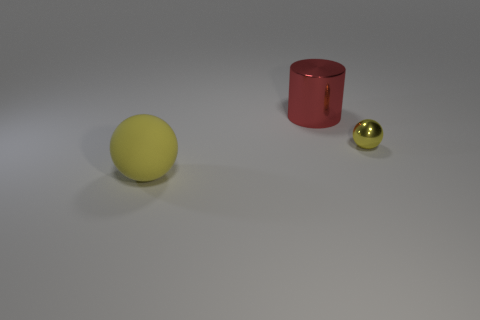There is a large object in front of the big red thing; is its shape the same as the red metallic thing?
Your answer should be very brief. No. How many things are either yellow objects or large red cylinders?
Offer a very short reply. 3. Is the object that is to the left of the large cylinder made of the same material as the red thing?
Your answer should be compact. No. The red metal thing is what size?
Provide a short and direct response. Large. There is a metal object that is the same color as the large rubber sphere; what is its shape?
Your answer should be very brief. Sphere. What number of blocks are large yellow rubber things or big red things?
Ensure brevity in your answer.  0. Are there an equal number of large balls that are in front of the large sphere and large yellow rubber balls that are to the left of the red cylinder?
Make the answer very short. No. There is a metal thing that is the same shape as the matte object; what is its size?
Your answer should be compact. Small. There is a thing that is behind the matte object and in front of the red metallic cylinder; how big is it?
Your answer should be compact. Small. There is a yellow shiny object; are there any big yellow rubber objects behind it?
Your answer should be compact. No. 